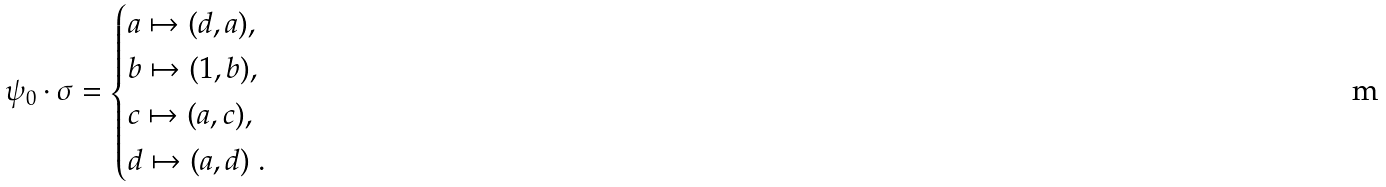Convert formula to latex. <formula><loc_0><loc_0><loc_500><loc_500>\psi _ { 0 } \cdot \sigma = \begin{cases} a \mapsto ( d , a ) , \\ b \mapsto ( 1 , b ) , \\ c \mapsto ( a , c ) , \\ d \mapsto ( a , d ) \ . \end{cases}</formula> 